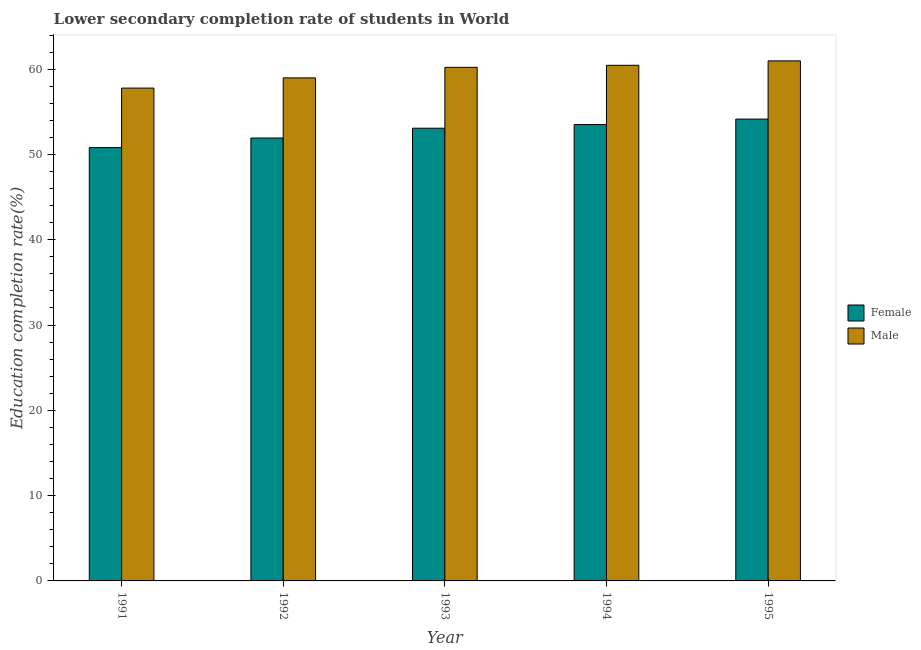How many groups of bars are there?
Ensure brevity in your answer.  5. What is the label of the 3rd group of bars from the left?
Offer a terse response. 1993. What is the education completion rate of male students in 1991?
Provide a short and direct response. 57.78. Across all years, what is the maximum education completion rate of male students?
Offer a terse response. 60.97. Across all years, what is the minimum education completion rate of male students?
Ensure brevity in your answer.  57.78. In which year was the education completion rate of female students maximum?
Provide a succinct answer. 1995. In which year was the education completion rate of male students minimum?
Offer a terse response. 1991. What is the total education completion rate of female students in the graph?
Your answer should be very brief. 263.47. What is the difference between the education completion rate of female students in 1991 and that in 1993?
Your answer should be compact. -2.27. What is the difference between the education completion rate of female students in 1994 and the education completion rate of male students in 1993?
Your answer should be very brief. 0.43. What is the average education completion rate of female students per year?
Your answer should be very brief. 52.69. What is the ratio of the education completion rate of female students in 1993 to that in 1994?
Offer a terse response. 0.99. Is the education completion rate of male students in 1991 less than that in 1995?
Make the answer very short. Yes. Is the difference between the education completion rate of male students in 1992 and 1993 greater than the difference between the education completion rate of female students in 1992 and 1993?
Your answer should be compact. No. What is the difference between the highest and the second highest education completion rate of female students?
Your response must be concise. 0.64. What is the difference between the highest and the lowest education completion rate of male students?
Keep it short and to the point. 3.19. What does the 2nd bar from the left in 1992 represents?
Make the answer very short. Male. What does the 1st bar from the right in 1992 represents?
Provide a succinct answer. Male. Are all the bars in the graph horizontal?
Offer a very short reply. No. What is the difference between two consecutive major ticks on the Y-axis?
Your response must be concise. 10. Are the values on the major ticks of Y-axis written in scientific E-notation?
Your answer should be very brief. No. Does the graph contain any zero values?
Provide a short and direct response. No. Does the graph contain grids?
Make the answer very short. No. Where does the legend appear in the graph?
Give a very brief answer. Center right. How many legend labels are there?
Your answer should be very brief. 2. How are the legend labels stacked?
Your answer should be compact. Vertical. What is the title of the graph?
Make the answer very short. Lower secondary completion rate of students in World. What is the label or title of the X-axis?
Your response must be concise. Year. What is the label or title of the Y-axis?
Your response must be concise. Education completion rate(%). What is the Education completion rate(%) of Female in 1991?
Your answer should be compact. 50.81. What is the Education completion rate(%) in Male in 1991?
Your answer should be compact. 57.78. What is the Education completion rate(%) of Female in 1992?
Give a very brief answer. 51.93. What is the Education completion rate(%) in Male in 1992?
Provide a short and direct response. 58.98. What is the Education completion rate(%) in Female in 1993?
Offer a terse response. 53.08. What is the Education completion rate(%) of Male in 1993?
Provide a short and direct response. 60.22. What is the Education completion rate(%) in Female in 1994?
Your response must be concise. 53.51. What is the Education completion rate(%) in Male in 1994?
Keep it short and to the point. 60.46. What is the Education completion rate(%) of Female in 1995?
Ensure brevity in your answer.  54.15. What is the Education completion rate(%) in Male in 1995?
Your answer should be compact. 60.97. Across all years, what is the maximum Education completion rate(%) in Female?
Give a very brief answer. 54.15. Across all years, what is the maximum Education completion rate(%) of Male?
Offer a very short reply. 60.97. Across all years, what is the minimum Education completion rate(%) in Female?
Provide a short and direct response. 50.81. Across all years, what is the minimum Education completion rate(%) of Male?
Give a very brief answer. 57.78. What is the total Education completion rate(%) in Female in the graph?
Your response must be concise. 263.47. What is the total Education completion rate(%) of Male in the graph?
Provide a short and direct response. 298.41. What is the difference between the Education completion rate(%) of Female in 1991 and that in 1992?
Offer a terse response. -1.12. What is the difference between the Education completion rate(%) in Male in 1991 and that in 1992?
Keep it short and to the point. -1.2. What is the difference between the Education completion rate(%) in Female in 1991 and that in 1993?
Provide a succinct answer. -2.27. What is the difference between the Education completion rate(%) in Male in 1991 and that in 1993?
Ensure brevity in your answer.  -2.43. What is the difference between the Education completion rate(%) in Female in 1991 and that in 1994?
Give a very brief answer. -2.7. What is the difference between the Education completion rate(%) in Male in 1991 and that in 1994?
Offer a very short reply. -2.67. What is the difference between the Education completion rate(%) of Female in 1991 and that in 1995?
Provide a short and direct response. -3.34. What is the difference between the Education completion rate(%) of Male in 1991 and that in 1995?
Make the answer very short. -3.19. What is the difference between the Education completion rate(%) of Female in 1992 and that in 1993?
Offer a very short reply. -1.15. What is the difference between the Education completion rate(%) of Male in 1992 and that in 1993?
Offer a terse response. -1.24. What is the difference between the Education completion rate(%) of Female in 1992 and that in 1994?
Ensure brevity in your answer.  -1.58. What is the difference between the Education completion rate(%) of Male in 1992 and that in 1994?
Your response must be concise. -1.48. What is the difference between the Education completion rate(%) of Female in 1992 and that in 1995?
Give a very brief answer. -2.22. What is the difference between the Education completion rate(%) in Male in 1992 and that in 1995?
Your answer should be very brief. -1.99. What is the difference between the Education completion rate(%) of Female in 1993 and that in 1994?
Your answer should be compact. -0.43. What is the difference between the Education completion rate(%) of Male in 1993 and that in 1994?
Offer a very short reply. -0.24. What is the difference between the Education completion rate(%) in Female in 1993 and that in 1995?
Provide a succinct answer. -1.07. What is the difference between the Education completion rate(%) in Male in 1993 and that in 1995?
Provide a succinct answer. -0.76. What is the difference between the Education completion rate(%) of Female in 1994 and that in 1995?
Keep it short and to the point. -0.64. What is the difference between the Education completion rate(%) in Male in 1994 and that in 1995?
Offer a very short reply. -0.52. What is the difference between the Education completion rate(%) in Female in 1991 and the Education completion rate(%) in Male in 1992?
Provide a succinct answer. -8.17. What is the difference between the Education completion rate(%) in Female in 1991 and the Education completion rate(%) in Male in 1993?
Provide a succinct answer. -9.41. What is the difference between the Education completion rate(%) of Female in 1991 and the Education completion rate(%) of Male in 1994?
Provide a succinct answer. -9.65. What is the difference between the Education completion rate(%) in Female in 1991 and the Education completion rate(%) in Male in 1995?
Provide a short and direct response. -10.16. What is the difference between the Education completion rate(%) of Female in 1992 and the Education completion rate(%) of Male in 1993?
Your response must be concise. -8.29. What is the difference between the Education completion rate(%) of Female in 1992 and the Education completion rate(%) of Male in 1994?
Provide a succinct answer. -8.53. What is the difference between the Education completion rate(%) of Female in 1992 and the Education completion rate(%) of Male in 1995?
Keep it short and to the point. -9.04. What is the difference between the Education completion rate(%) in Female in 1993 and the Education completion rate(%) in Male in 1994?
Offer a very short reply. -7.38. What is the difference between the Education completion rate(%) in Female in 1993 and the Education completion rate(%) in Male in 1995?
Offer a terse response. -7.89. What is the difference between the Education completion rate(%) of Female in 1994 and the Education completion rate(%) of Male in 1995?
Provide a succinct answer. -7.47. What is the average Education completion rate(%) in Female per year?
Ensure brevity in your answer.  52.69. What is the average Education completion rate(%) in Male per year?
Offer a terse response. 59.68. In the year 1991, what is the difference between the Education completion rate(%) of Female and Education completion rate(%) of Male?
Offer a very short reply. -6.97. In the year 1992, what is the difference between the Education completion rate(%) in Female and Education completion rate(%) in Male?
Your answer should be compact. -7.05. In the year 1993, what is the difference between the Education completion rate(%) in Female and Education completion rate(%) in Male?
Provide a succinct answer. -7.14. In the year 1994, what is the difference between the Education completion rate(%) in Female and Education completion rate(%) in Male?
Ensure brevity in your answer.  -6.95. In the year 1995, what is the difference between the Education completion rate(%) in Female and Education completion rate(%) in Male?
Your answer should be compact. -6.83. What is the ratio of the Education completion rate(%) of Female in 1991 to that in 1992?
Keep it short and to the point. 0.98. What is the ratio of the Education completion rate(%) in Male in 1991 to that in 1992?
Your answer should be very brief. 0.98. What is the ratio of the Education completion rate(%) in Female in 1991 to that in 1993?
Keep it short and to the point. 0.96. What is the ratio of the Education completion rate(%) in Male in 1991 to that in 1993?
Provide a succinct answer. 0.96. What is the ratio of the Education completion rate(%) of Female in 1991 to that in 1994?
Offer a very short reply. 0.95. What is the ratio of the Education completion rate(%) of Male in 1991 to that in 1994?
Ensure brevity in your answer.  0.96. What is the ratio of the Education completion rate(%) in Female in 1991 to that in 1995?
Your response must be concise. 0.94. What is the ratio of the Education completion rate(%) of Male in 1991 to that in 1995?
Your answer should be very brief. 0.95. What is the ratio of the Education completion rate(%) in Female in 1992 to that in 1993?
Offer a terse response. 0.98. What is the ratio of the Education completion rate(%) in Male in 1992 to that in 1993?
Ensure brevity in your answer.  0.98. What is the ratio of the Education completion rate(%) of Female in 1992 to that in 1994?
Offer a very short reply. 0.97. What is the ratio of the Education completion rate(%) in Male in 1992 to that in 1994?
Your answer should be very brief. 0.98. What is the ratio of the Education completion rate(%) in Male in 1992 to that in 1995?
Provide a short and direct response. 0.97. What is the ratio of the Education completion rate(%) of Female in 1993 to that in 1994?
Make the answer very short. 0.99. What is the ratio of the Education completion rate(%) in Male in 1993 to that in 1994?
Your answer should be very brief. 1. What is the ratio of the Education completion rate(%) of Female in 1993 to that in 1995?
Offer a very short reply. 0.98. What is the ratio of the Education completion rate(%) in Male in 1993 to that in 1995?
Your response must be concise. 0.99. What is the ratio of the Education completion rate(%) of Male in 1994 to that in 1995?
Your answer should be compact. 0.99. What is the difference between the highest and the second highest Education completion rate(%) of Female?
Your answer should be very brief. 0.64. What is the difference between the highest and the second highest Education completion rate(%) of Male?
Offer a terse response. 0.52. What is the difference between the highest and the lowest Education completion rate(%) of Female?
Make the answer very short. 3.34. What is the difference between the highest and the lowest Education completion rate(%) in Male?
Provide a succinct answer. 3.19. 